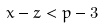Convert formula to latex. <formula><loc_0><loc_0><loc_500><loc_500>x - z < p - 3</formula> 